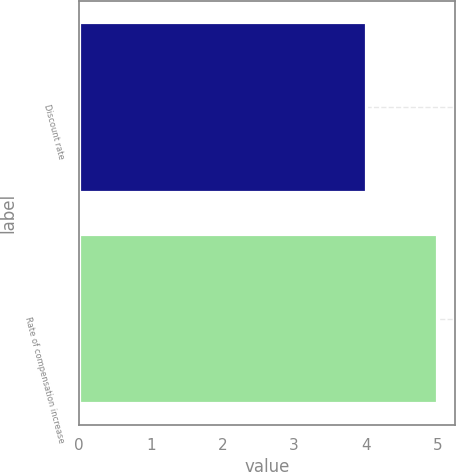Convert chart. <chart><loc_0><loc_0><loc_500><loc_500><bar_chart><fcel>Discount rate<fcel>Rate of compensation increase<nl><fcel>4.01<fcel>5<nl></chart> 